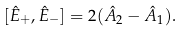<formula> <loc_0><loc_0><loc_500><loc_500>[ \hat { E } _ { + } , \hat { E } _ { - } ] = 2 ( \hat { A } _ { 2 } - \hat { A } _ { 1 } ) .</formula> 